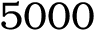Convert formula to latex. <formula><loc_0><loc_0><loc_500><loc_500>5 0 0 0</formula> 